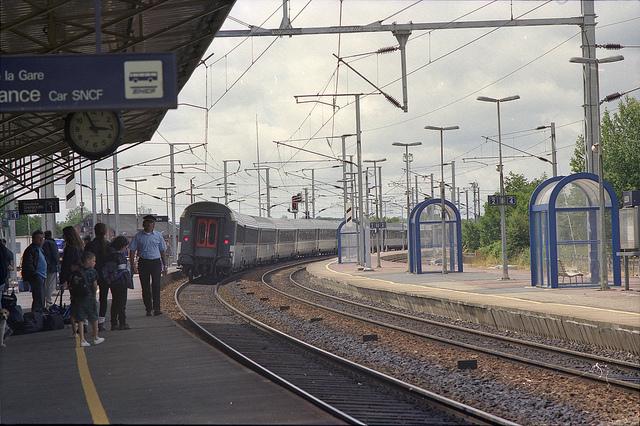Are the people waiting for the train to arrive?
Answer briefly. Yes. Can you see anyone walking down the tracks?
Quick response, please. No. Are people waiting for the train?
Write a very short answer. Yes. Are there any people in front of the yellow line?
Be succinct. Yes. Did the train just arrive?
Be succinct. No. Are there wires shown?
Answer briefly. Yes. 